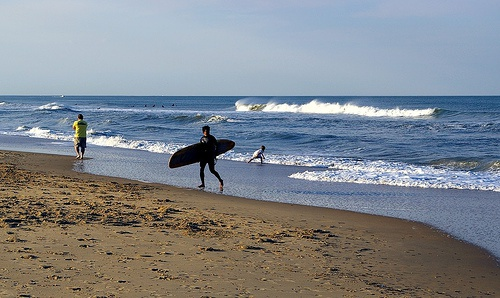Describe the objects in this image and their specific colors. I can see surfboard in lightblue, black, gray, and darkgray tones, people in lightblue, black, darkgreen, and darkgray tones, people in lightblue, black, gray, and darkgray tones, and people in lightblue, black, darkgray, lightgray, and gray tones in this image. 